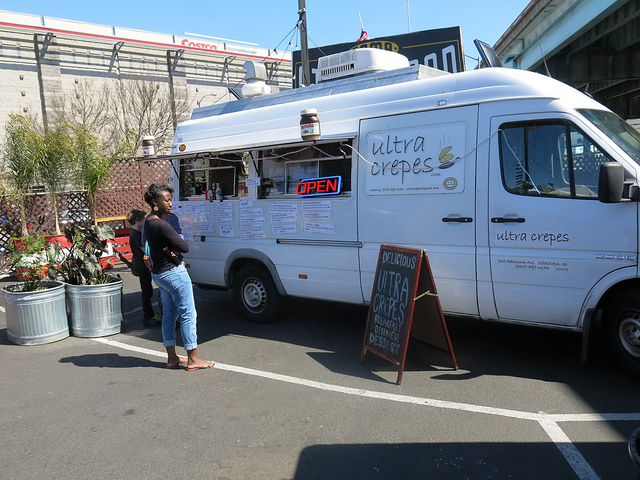How many potted plants are visible? There are a total of three potted plants visible, artfully arranged near the food truck to create a welcoming atmosphere for customers. 